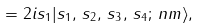<formula> <loc_0><loc_0><loc_500><loc_500>= 2 i s _ { 1 } | s _ { 1 } , \, s _ { 2 } , \, s _ { 3 } , \, s _ { 4 } ; \, n m \rangle ,</formula> 